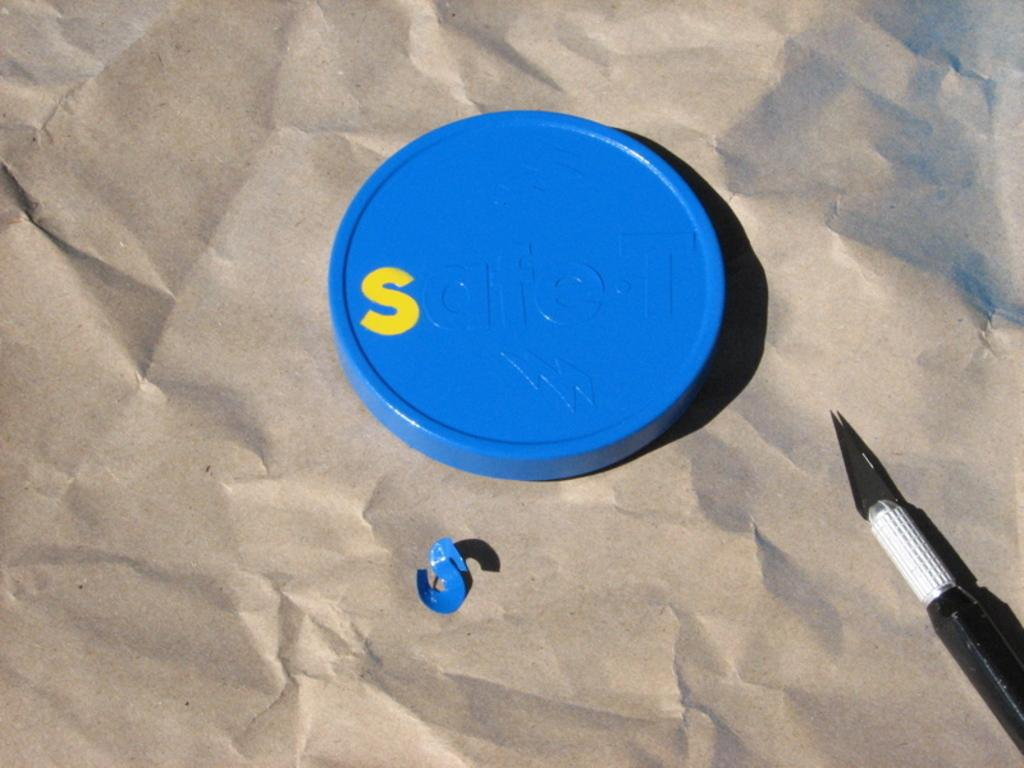What color is the lid that is visible in the image? The lid in the image is blue. What type of object is at the bottom of the image? There is a paper in brown color at the bottom of the image. Where is the knife located in the image? The knife is on the right side of the image. What role does the government play in the industry depicted in the image? There is no depiction of an industry or government in the image; it only features a blue lid, a brown paper, and a knife. 